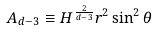<formula> <loc_0><loc_0><loc_500><loc_500>A _ { d - 3 } \equiv H ^ { \frac { 2 } { d - 3 } } r ^ { 2 } \sin ^ { 2 } \theta</formula> 